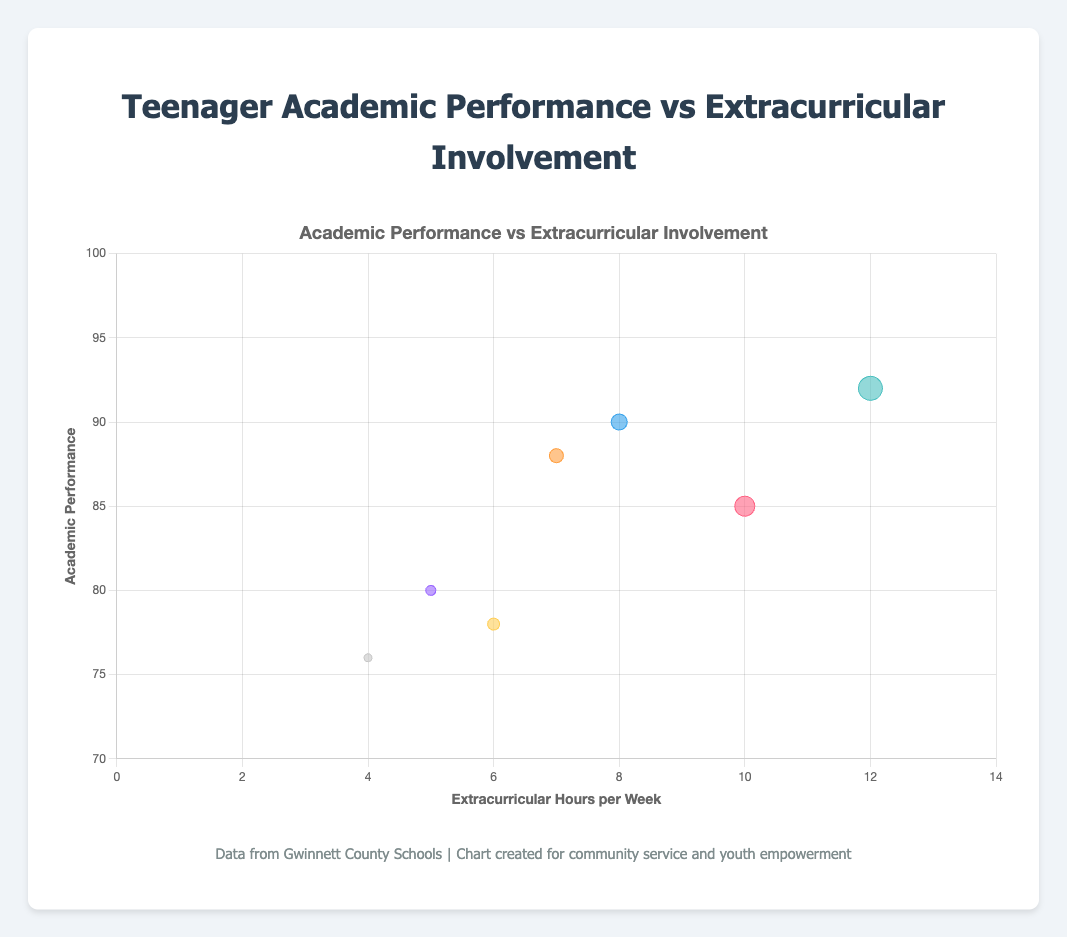How many students are represented in the chart? Look at the number of data points represented by bubbles in the chart. Each bubble represents one student. Count the number of bubbles to get the total number of students.
Answer: 7 Which student has the highest academic performance? Locate the highest point on the y-axis, which represents academic performance. Hover over or identify the bubble closest to the highest value. The tooltip/data label should indicate the student's name.
Answer: Emily Davis Which school has the student with the least extracurricular involvement? Look for the lowest value on the x-axis, which represents extracurricular hours per week. The corresponding bubble represents the student with the least involvement.
Answer: Parkview High School What is the average academic performance of the students from Norcross High School and Duluth High School? Identify the academic performance values for students from Norcross High School (85) and Duluth High School (90). Compute the average: (85 + 90) / 2 = 87.5
Answer: 87.5 How many students are involved in activities related to the arts (Drama Club and Marching Band)? Identify the bubbles representing students involved in Drama Club and Marching Band. Count the number of these bubbles.
Answer: 2 Which school has a student involved in the Environmental Club, and what is their academic performance? Find the bubble representing the Environmental Club (Sarah Wilson, Berkmar High School) and note its position on the y-axis for academic performance.
Answer: Berkmar High School, 88 Who spends the most hours on extracurricular activities, and what is their academic performance? Locate the highest point on the x-axis, which represents the number of extracurricular hours. Determine the bubble at this position and identify the student's academic performance from the tooltip/data label.
Answer: Emily Davis, 92 Compare the academic performance of students from Meadowcreek High School and Parkview High School. Who performs better academically? Identify the academic performance values of students from Meadowcreek High School (80) and Parkview High School (76). Compare the values to determine who performs better.
Answer: Meadowcreek High School Who is involved in the Debate Club, and how many hours per week do they spend on it? Find the bubble representing the Debate Club (Jane Smith). Check its position on the x-axis for the number of extracurricular hours.
Answer: Jane Smith, 8 What's the relationship between extracurricular hours and academic performance for the student at Peachtree Ridge High School? Identify the bubble for Peachtree Ridge High School (Tom Johnson), noting his academic performance (78) and extracurricular hours per week (6) to understand the relative position.
Answer: Tom Johnson has moderate academic performance at 78 and spends 6 hours per week on extracurricular activities 